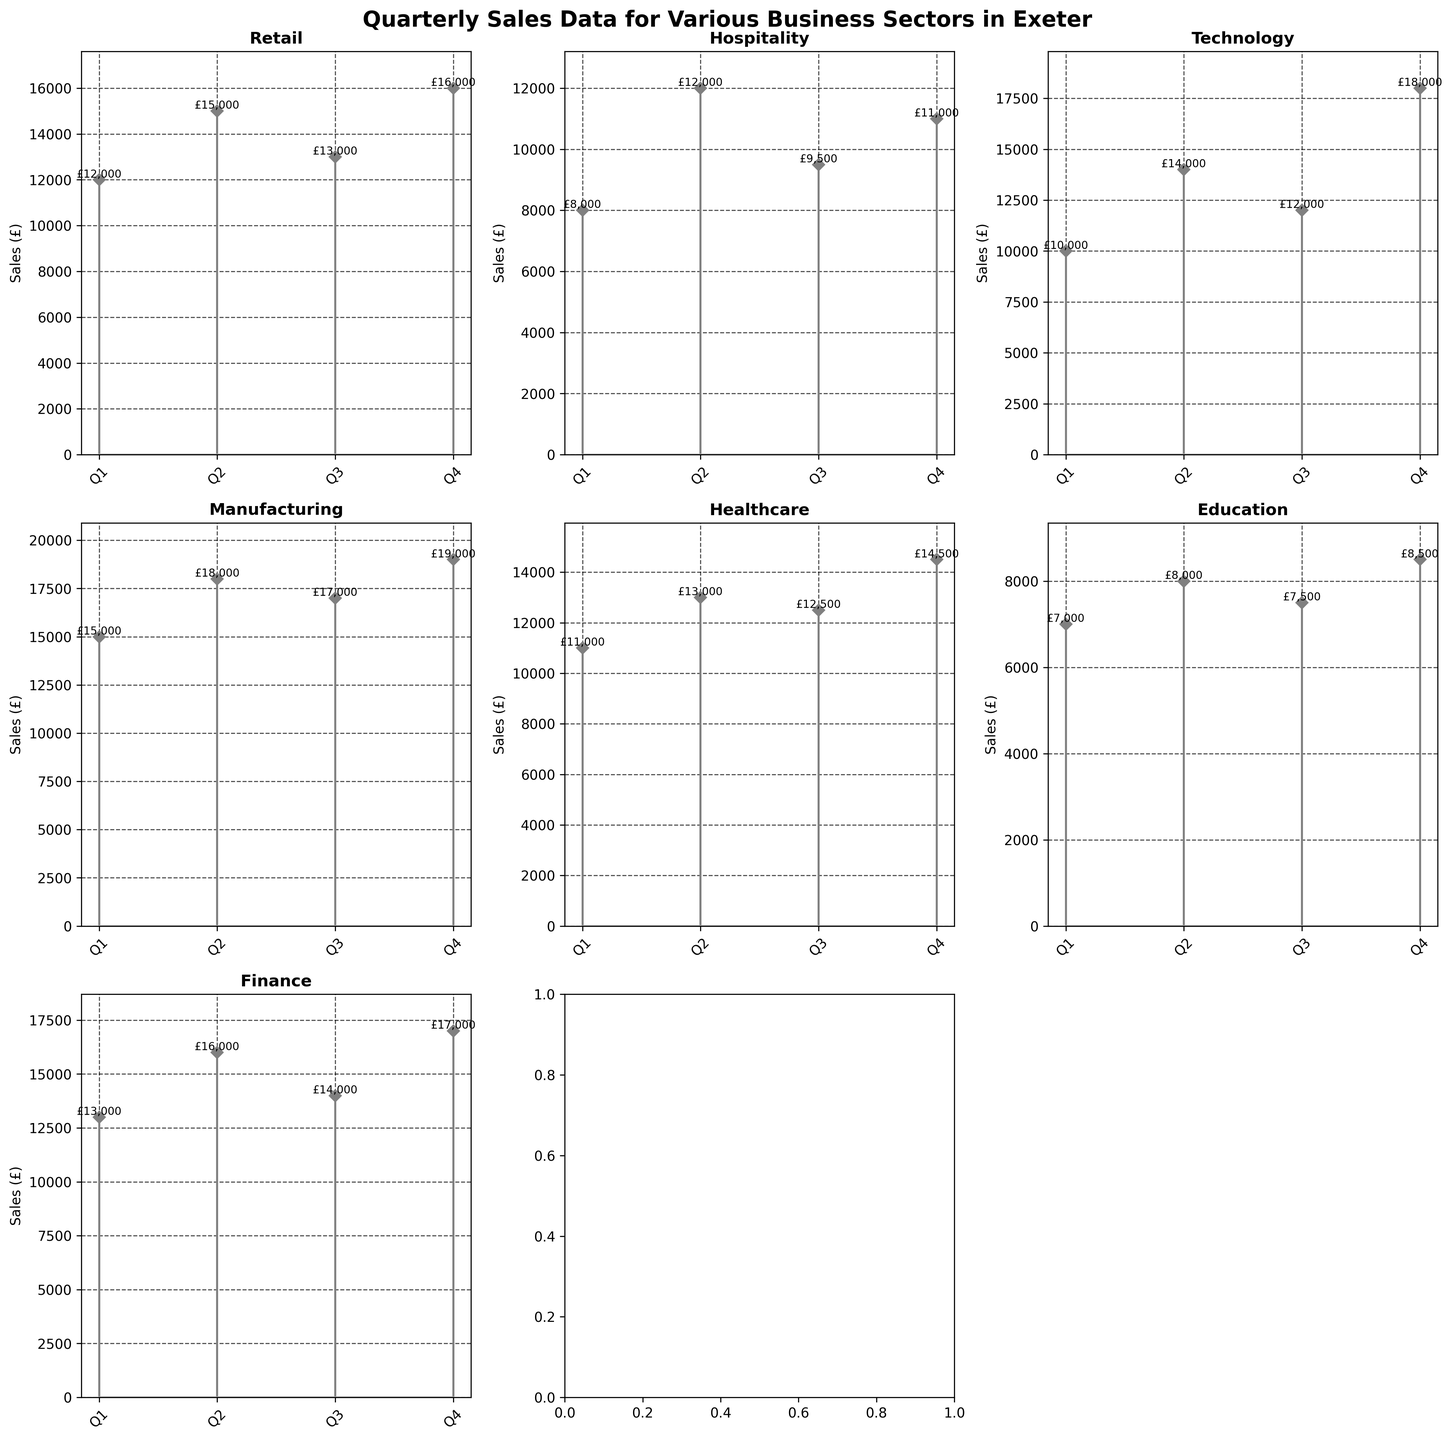What is the title of the figure? The title is displayed at the top of the figure. It reads "Quarterly Sales Data for Various Business Sectors in Exeter".
Answer: Quarterly Sales Data for Various Business Sectors in Exeter How many sectors are displayed in the figure? The figure shows individual subplots titled by each sector. Counting the titles, there are 8 sectors displayed.
Answer: 8 Which sector had the highest sales in Q4? Looking at the Q4 data points of all sectors, Manufacturing has the highest Q4 sales, reaching £19,000.
Answer: Manufacturing What is the total sales for the Retail sector across all quarters? Sum the sales values for the Retail sector in each quarter: 12,000 + 15,000 + 13,000 + 16,000 = 56,000.
Answer: 56,000 Which sector had the lowest sales in Q1 and what was the value? By checking the Q1 sales for all sectors, Education has the lowest sales in Q1, which is £7,000.
Answer: Education, £7,000 Which quarters did the Hospitality sector's sales exceed £10,000? Examining the Hospitality sector's sales in each quarter, they exceeded £10,000 in Q2, Q3, and Q4 with sales of £12,000, £9,500, and £11,000 respectively.
Answer: Q2, Q4 What is the average sales for the Finance sector? To find the average, sum the Finance sector’s sales and divide by the number of data points: (13,000 + 16,000 + 14,000 + 17,000) / 4 = £15,000.
Answer: £15,000 Which sector has the most fluctuating quarterly sales? Fluctuation can be observed by looking at peaks and troughs in the stem plots. Education shows relatively consistent sales, whereas the Technology sector, varying between £10,000, £14,000, £12,000, and £18,000, appears to have a lot of fluctuation.
Answer: Technology What is the difference between the highest and lowest sales in the Healthcare sector? Identify the highest and lowest quarter sales for Healthcare: highest is £14,500 (Q4), lowest is £11,000 (Q1). The difference is £14,500 - £11,000 = £3,500.
Answer: £3,500 